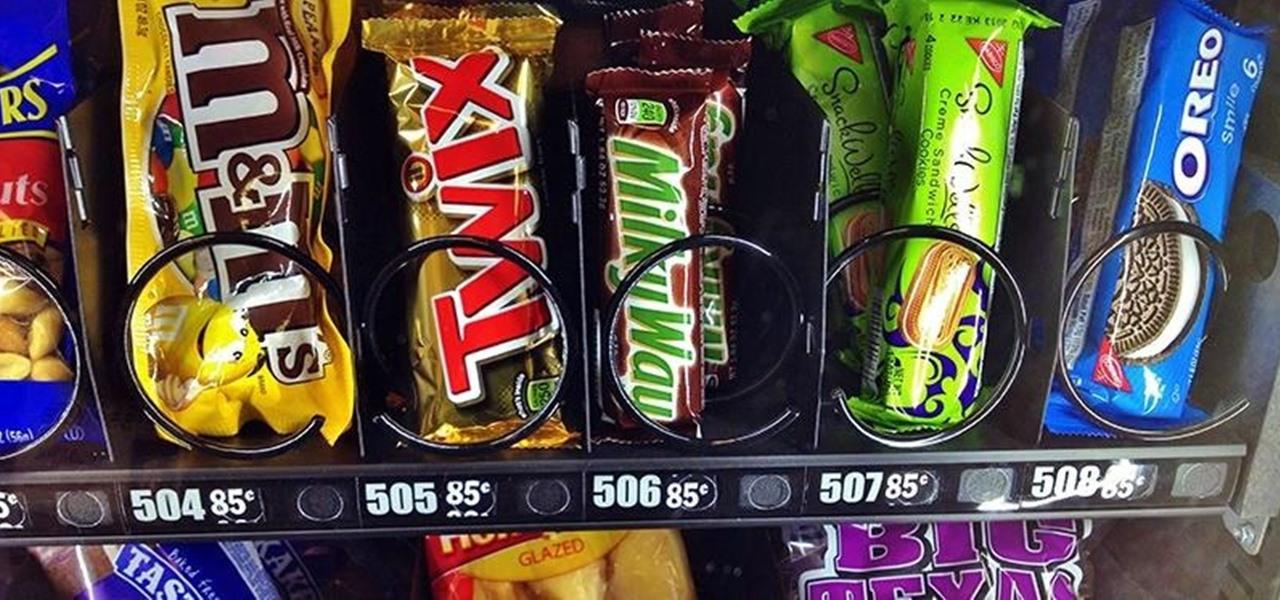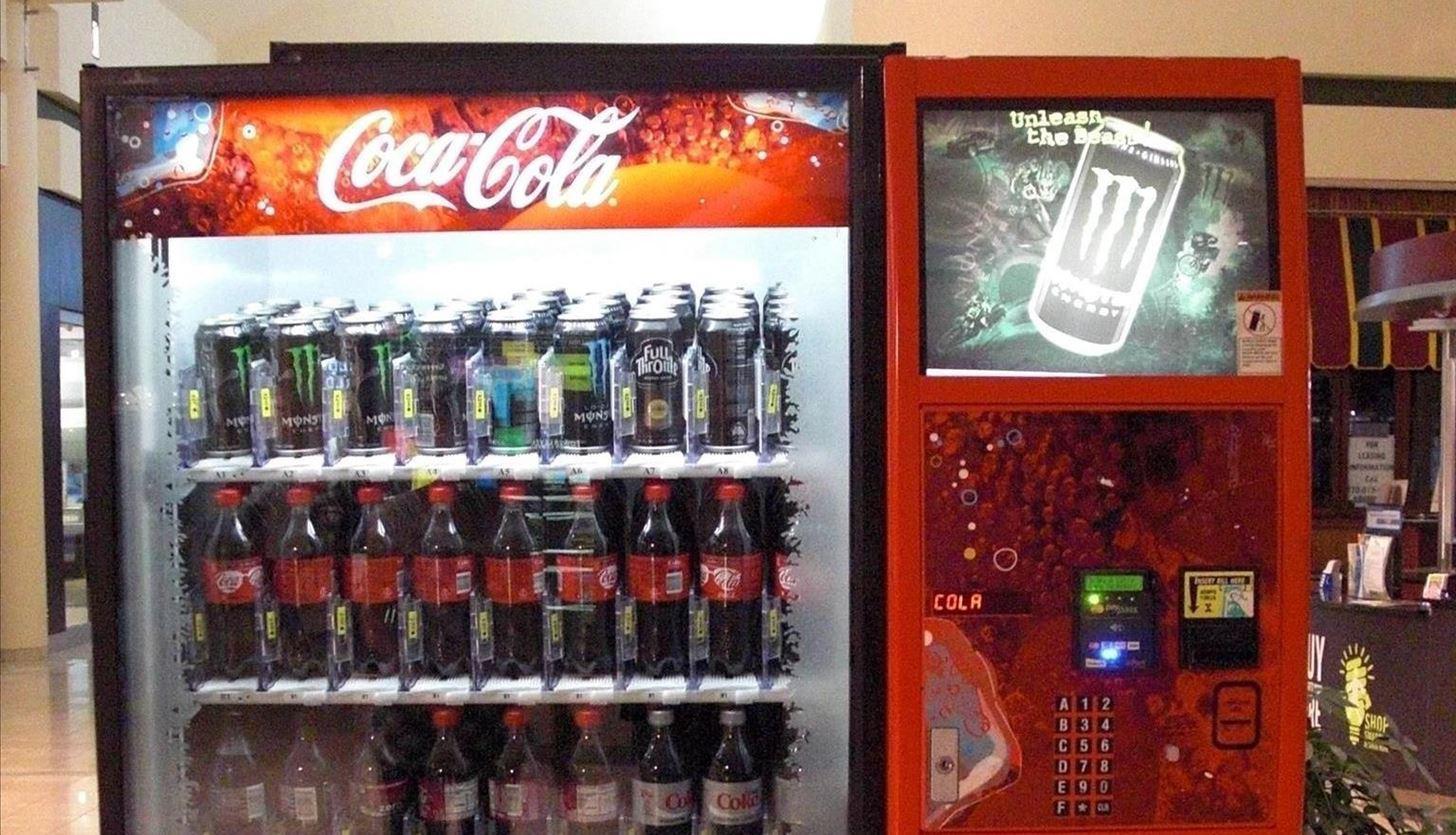The first image is the image on the left, the second image is the image on the right. For the images displayed, is the sentence "All images only show beverages." factually correct? Answer yes or no. No. 